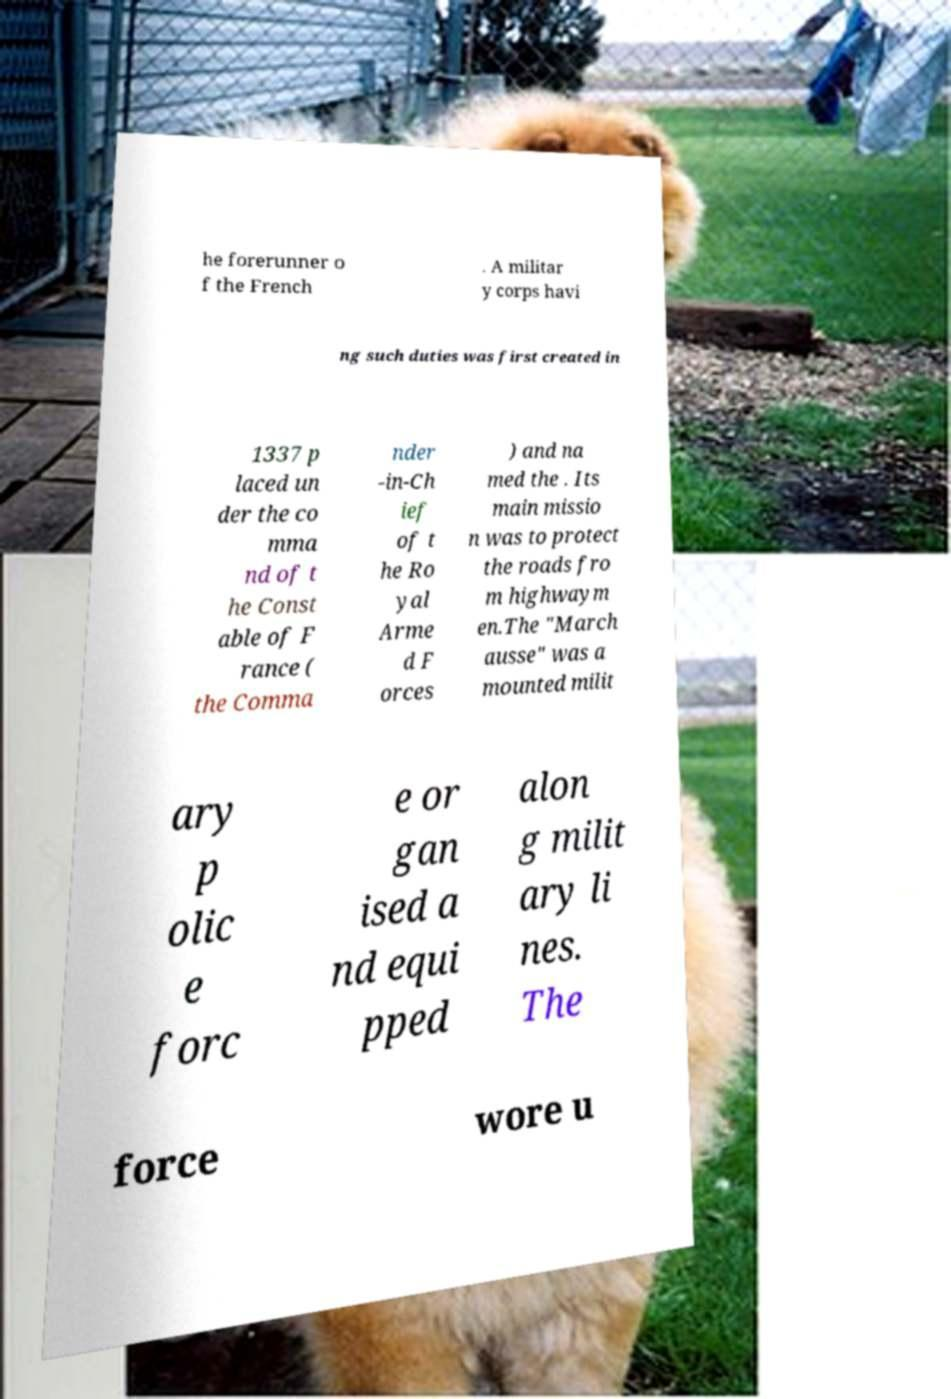Can you accurately transcribe the text from the provided image for me? he forerunner o f the French . A militar y corps havi ng such duties was first created in 1337 p laced un der the co mma nd of t he Const able of F rance ( the Comma nder -in-Ch ief of t he Ro yal Arme d F orces ) and na med the . Its main missio n was to protect the roads fro m highwaym en.The "March ausse" was a mounted milit ary p olic e forc e or gan ised a nd equi pped alon g milit ary li nes. The force wore u 